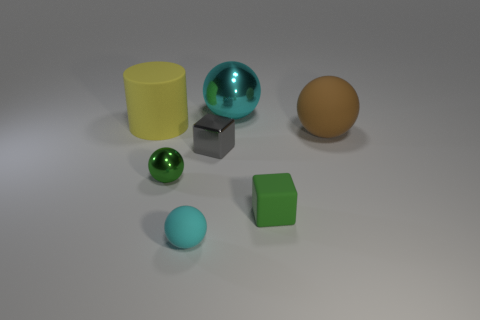What materials are the objects in the image likely made of? The objects in the image appear to be made of different materials. The green and blue spheres seem to be made of a matte finish plastic, the brown object could be ceramic or wooden, the shiny teal sphere looks metallic, and the gray cube also has a metallic sheen. The yellow cylinder could be a plastic container. 